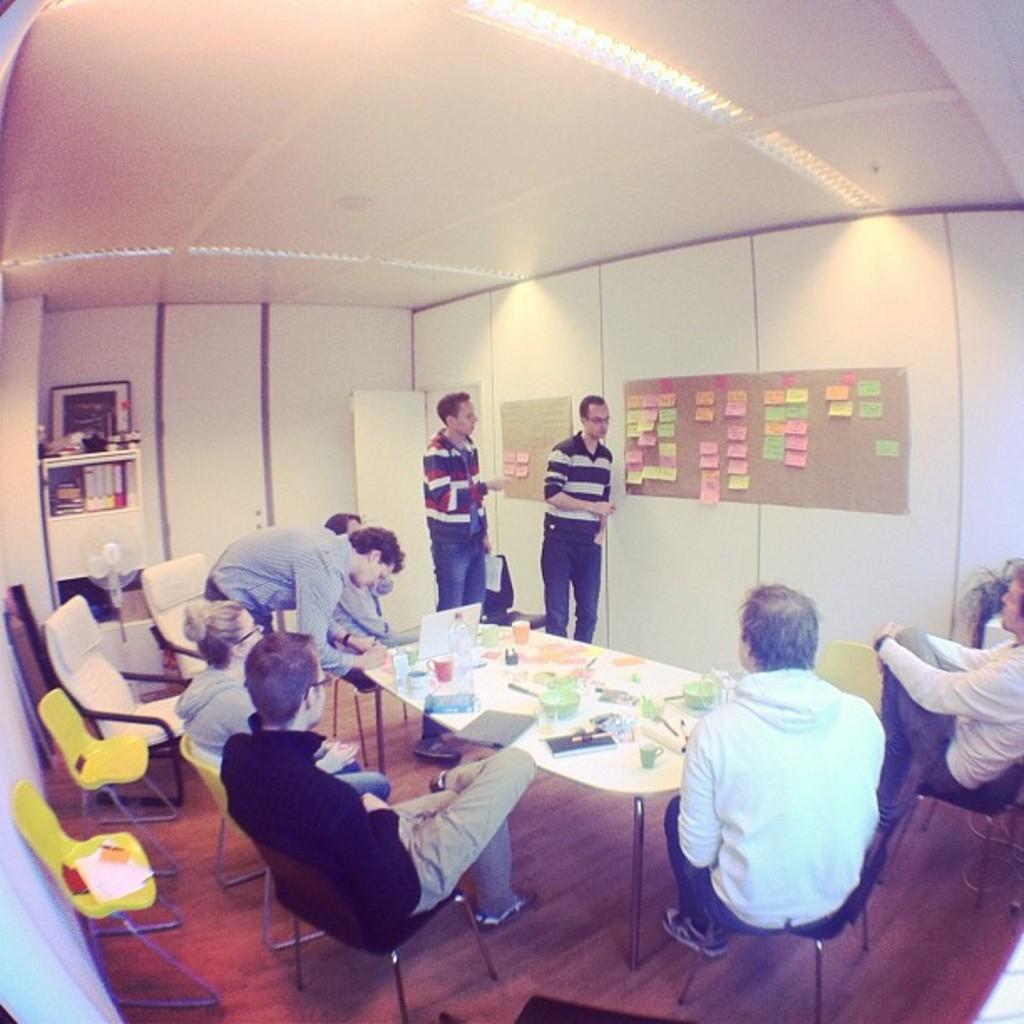Describe this image in one or two sentences. A picture inside of a room. On wall there are notes. Far in a race there are book. These persons are sitting on a chair. This 2 persons are standing. On this table there is a coffee mug, book, pen, pen and laptop. 